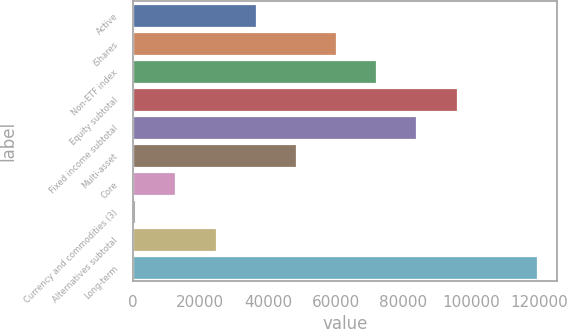Convert chart to OTSL. <chart><loc_0><loc_0><loc_500><loc_500><bar_chart><fcel>Active<fcel>iShares<fcel>Non-ETF index<fcel>Equity subtotal<fcel>Fixed income subtotal<fcel>Multi-asset<fcel>Core<fcel>Currency and commodities (3)<fcel>Alternatives subtotal<fcel>Long-term<nl><fcel>36360.3<fcel>60108.5<fcel>71982.6<fcel>95730.8<fcel>83856.7<fcel>48234.4<fcel>12612.1<fcel>738<fcel>24486.2<fcel>119479<nl></chart> 